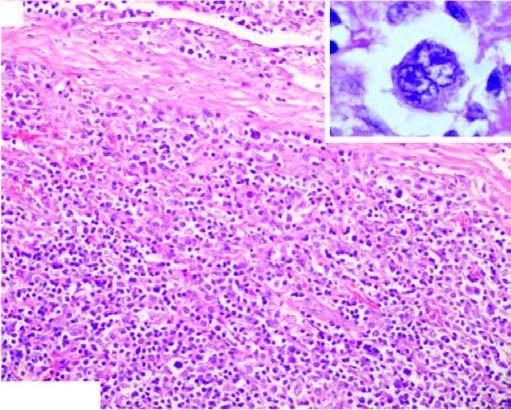what are there of collagen forming nodules and characteristic lacunar rs cells?
Answer the question using a single word or phrase. Bands 